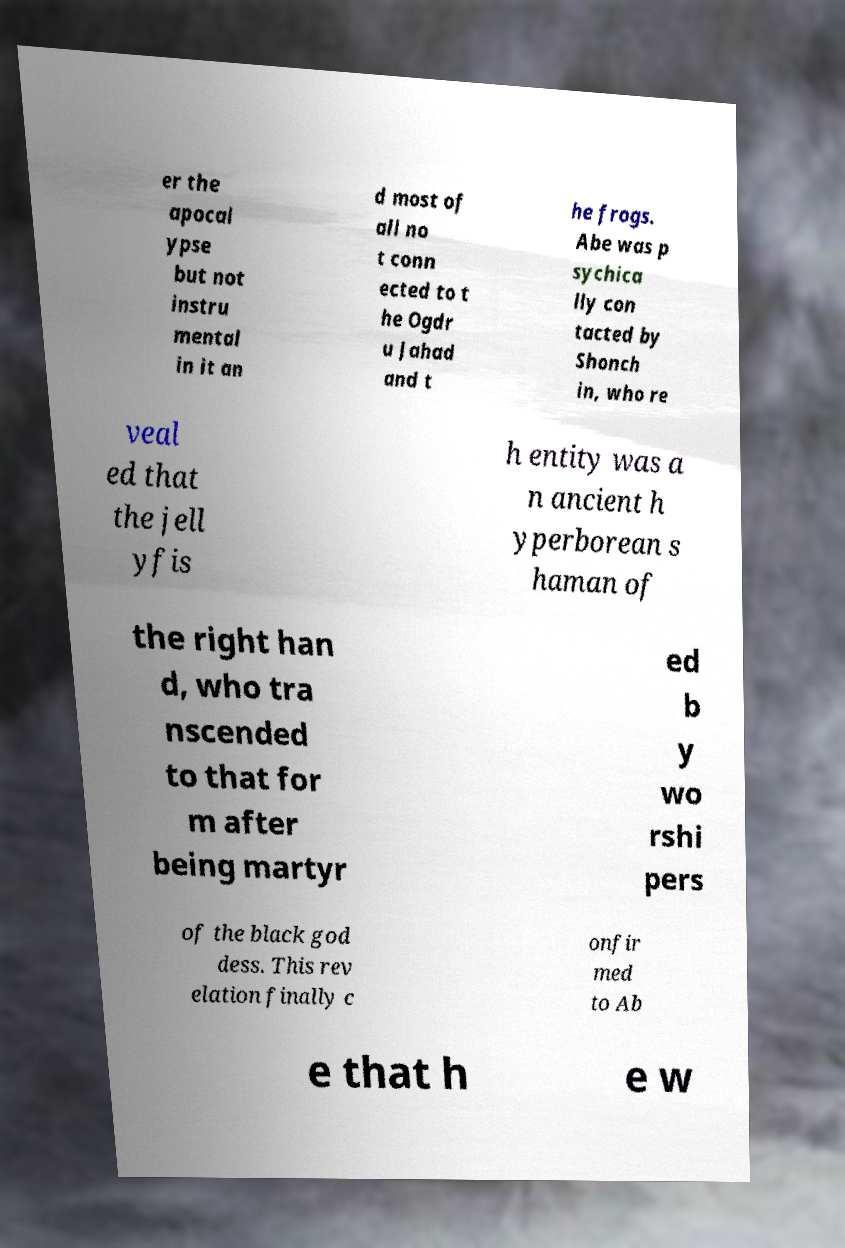Can you read and provide the text displayed in the image?This photo seems to have some interesting text. Can you extract and type it out for me? er the apocal ypse but not instru mental in it an d most of all no t conn ected to t he Ogdr u Jahad and t he frogs. Abe was p sychica lly con tacted by Shonch in, who re veal ed that the jell yfis h entity was a n ancient h yperborean s haman of the right han d, who tra nscended to that for m after being martyr ed b y wo rshi pers of the black god dess. This rev elation finally c onfir med to Ab e that h e w 